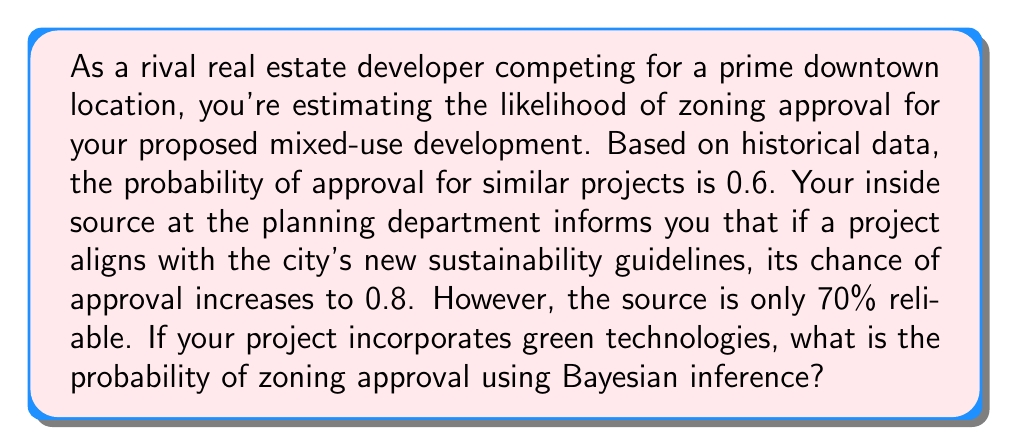Could you help me with this problem? Let's approach this step-by-step using Bayesian inference:

1) Define our events:
   A: Zoning approval
   B: Project aligns with sustainability guidelines

2) Given probabilities:
   P(A) = 0.6 (prior probability of approval)
   P(B|A) = 0.8 (probability of alignment given approval)
   P(B) = 0.7 (reliability of the source)

3) We want to find P(A|B) using Bayes' theorem:

   $$P(A|B) = \frac{P(B|A) \cdot P(A)}{P(B)}$$

4) Calculate P(B|A) · P(A):
   $$P(B|A) \cdot P(A) = 0.8 \cdot 0.6 = 0.48$$

5) Substitute into Bayes' theorem:
   $$P(A|B) = \frac{0.48}{0.7} \approx 0.6857$$

6) Convert to percentage:
   0.6857 * 100 ≈ 68.57%

Therefore, given that your project incorporates green technologies (aligning with sustainability guidelines), and considering the reliability of your source, the probability of zoning approval is approximately 68.57%.
Answer: 68.57% 